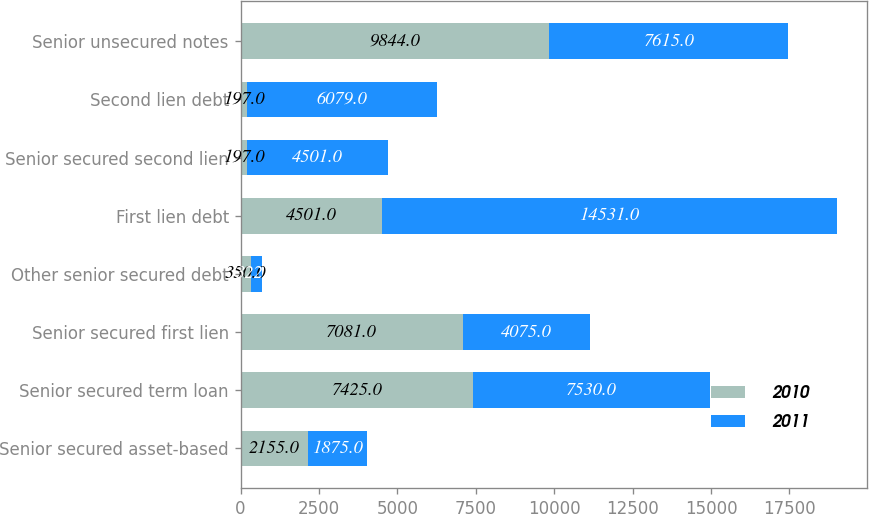<chart> <loc_0><loc_0><loc_500><loc_500><stacked_bar_chart><ecel><fcel>Senior secured asset-based<fcel>Senior secured term loan<fcel>Senior secured first lien<fcel>Other senior secured debt<fcel>First lien debt<fcel>Senior secured second lien<fcel>Second lien debt<fcel>Senior unsecured notes<nl><fcel>2010<fcel>2155<fcel>7425<fcel>7081<fcel>350<fcel>4501<fcel>197<fcel>197<fcel>9844<nl><fcel>2011<fcel>1875<fcel>7530<fcel>4075<fcel>322<fcel>14531<fcel>4501<fcel>6079<fcel>7615<nl></chart> 